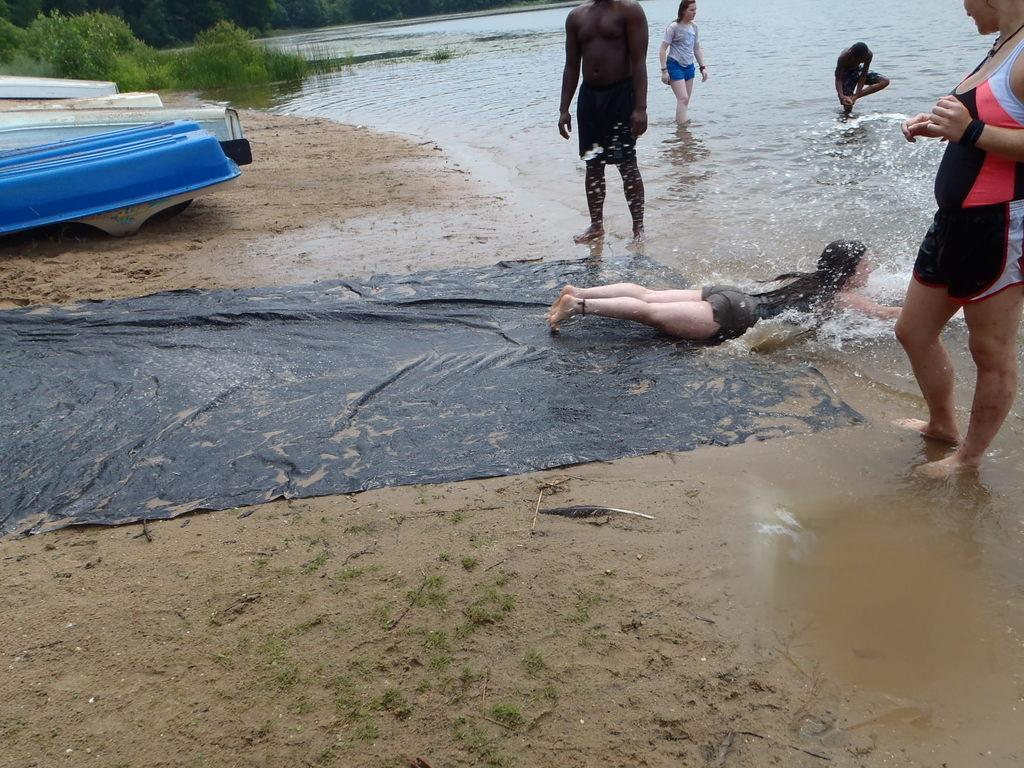How many people are in the image? There is a group of people in the image. What is the woman in the image doing? A woman is lying on the water in the image. What object can be seen in the image that is used for covering or protection? There is a sheet in the image. What type of transportation is present in the image? There are boats in the image. What type of vegetation is visible in the image? There are trees in the image. How many cats are paying attention to the woman lying on the water in the image? There are no cats present in the image. What color is the woman's nose in the image? The image does not provide information about the color of the woman's nose. 